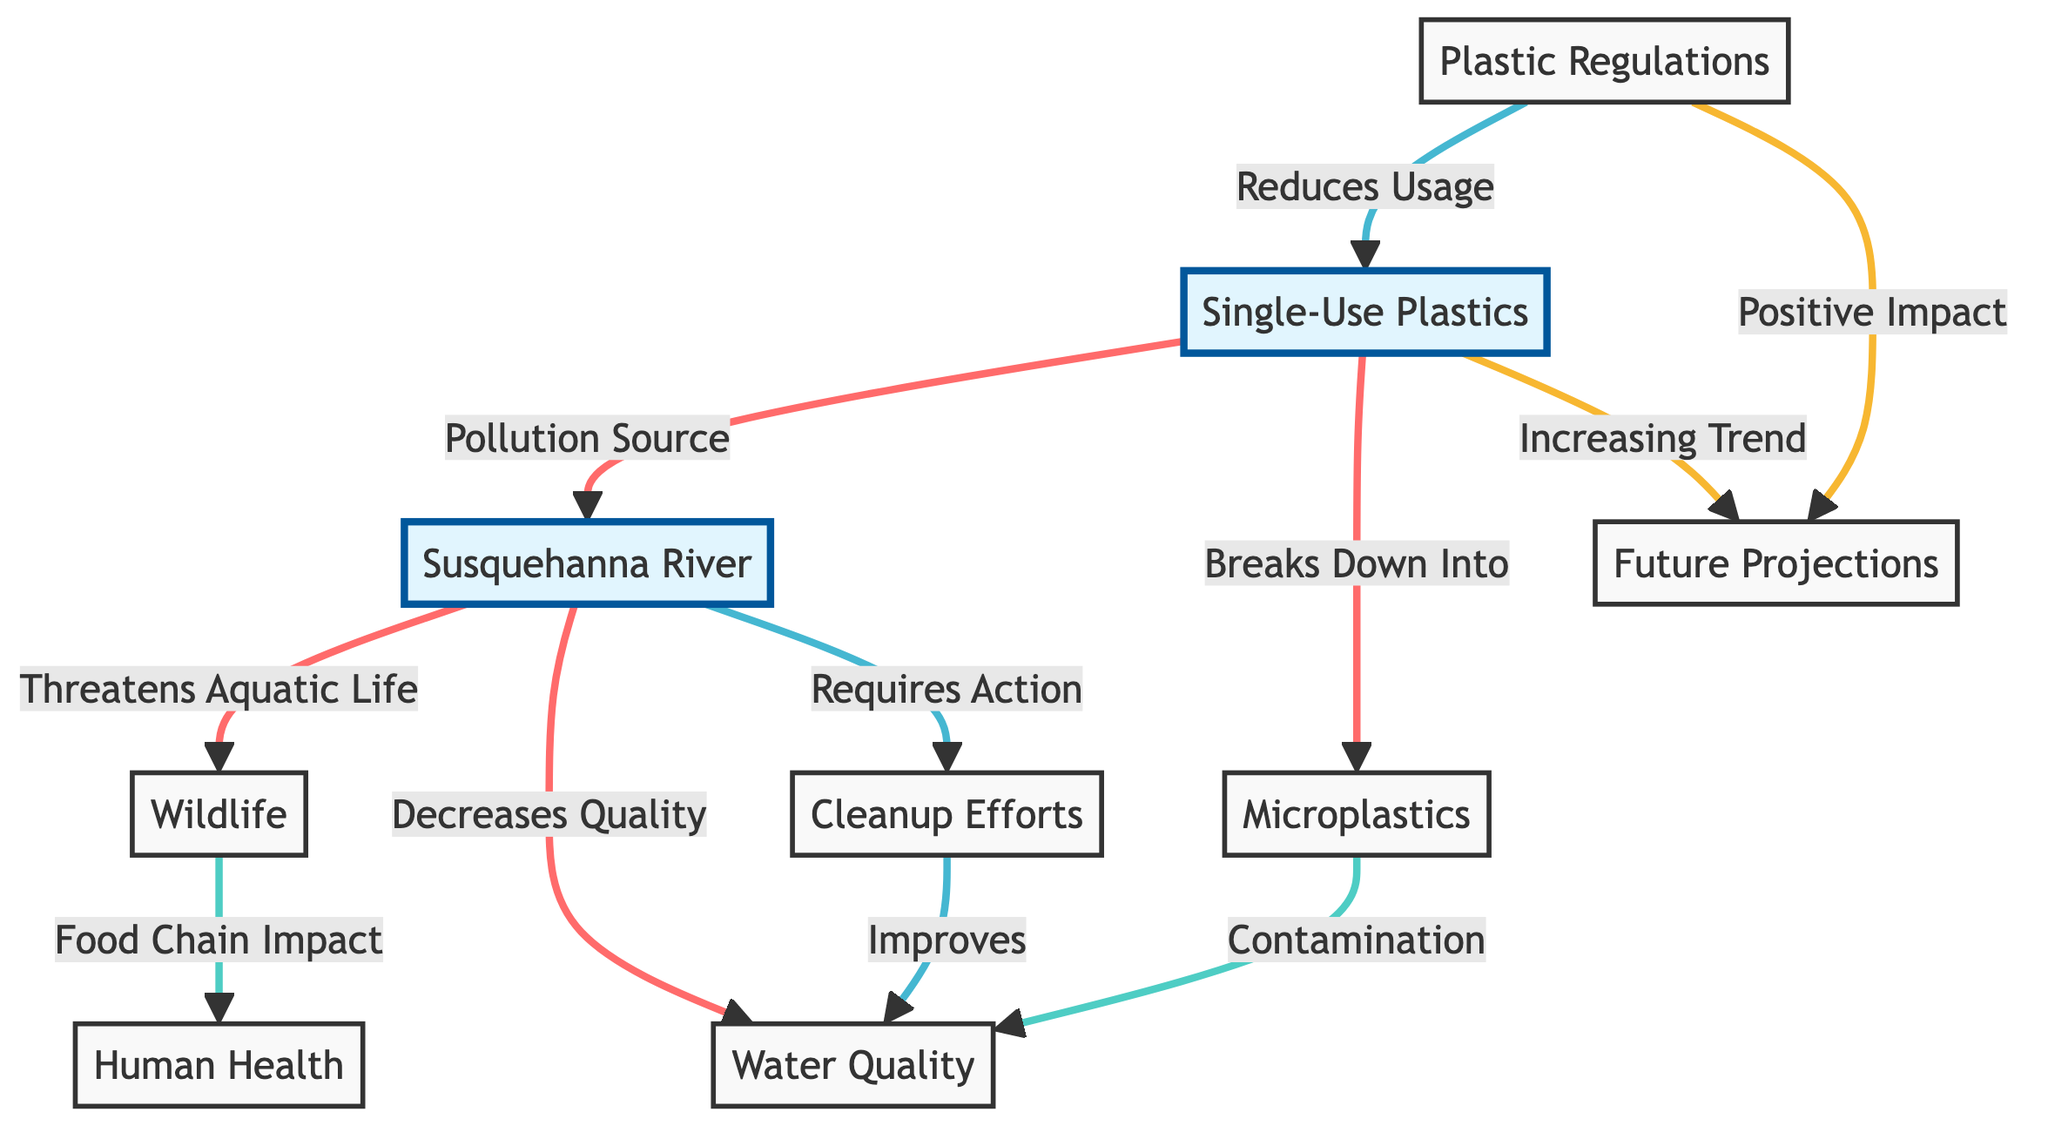What is the main pollution source affecting the Susquehanna River? The diagram indicates that the main pollution source is "Single-Use Plastics," as labeled in the flowchart directing towards the river.
Answer: Single-Use Plastics How many main consequences of pollution are shown in the diagram? The diagram identifies three main consequences stemming from the pollution: Threat to Wildlife, Decrease in Water Quality, and Cleanup Efforts, represented by three connecting nodes from the Susquehanna River.
Answer: Three What are the two impacts of microplastics in the ecosystem? The diagram shows that microplastics have two impacts: contamination of Water Quality and an impact on the Food Chain affecting Human Health, as indicated by two separate connections from the microplastics node.
Answer: Contamination, Food Chain Impact How does legislation affect single-use plastics? The flowchart illustrates that "Plastic Regulations" lead to a reduction in the usage of "Single-Use Plastics," which is depicted as a direct connection showcasing their relationship in the environmental context.
Answer: Reduces Usage What kind of action is required for the Susquehanna River? The flowchart indicates that the Susquehanna River "Requires Action," which is represented by the node labeled as "Cleanup Efforts," directly connected from the river node itself.
Answer: Cleanup Efforts What is the future projection trend regarding single-use plastics? The diagram shows that there is an "Increasing Trend" in single-use plastics, as indicated by the arrow from the single-use plastics node to the future projections node, showing anticipated growth.
Answer: Increasing Trend What is the effect of cleanup efforts on water quality? According to the flowchart, "Cleanup Efforts" are shown to have a positive impact on "Water Quality," connecting directly to the water quality node and indicating an improvement due to these efforts.
Answer: Improves What happens to wildlife due to pollution in the river? The diagram indicates that pollution in the Susquehanna River threatens "Wildlife," as suggested by the direct connection from the pollution source to the wildlife node.
Answer: Threatens Aquatic Life What is the relationship between human health and wildlife? The flowchart connects the impact of "Wildlife" on the "Food Chain Impact," which then links to "Human Health," signifying that threats to wildlife directly contribute to health concerns for humans.
Answer: Food Chain Impact 